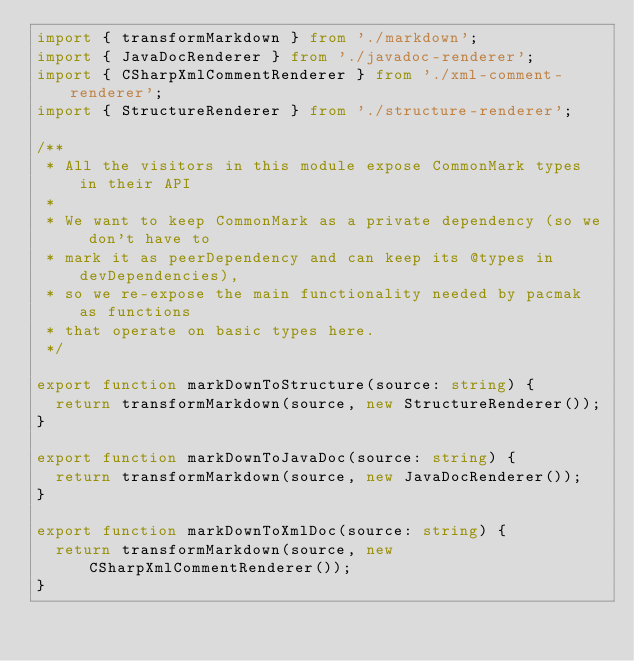Convert code to text. <code><loc_0><loc_0><loc_500><loc_500><_TypeScript_>import { transformMarkdown } from './markdown';
import { JavaDocRenderer } from './javadoc-renderer';
import { CSharpXmlCommentRenderer } from './xml-comment-renderer';
import { StructureRenderer } from './structure-renderer';

/**
 * All the visitors in this module expose CommonMark types in their API
 *
 * We want to keep CommonMark as a private dependency (so we don't have to
 * mark it as peerDependency and can keep its @types in devDependencies),
 * so we re-expose the main functionality needed by pacmak as functions
 * that operate on basic types here.
 */

export function markDownToStructure(source: string) {
  return transformMarkdown(source, new StructureRenderer());
}

export function markDownToJavaDoc(source: string) {
  return transformMarkdown(source, new JavaDocRenderer());
}

export function markDownToXmlDoc(source: string) {
  return transformMarkdown(source, new CSharpXmlCommentRenderer());
}
</code> 